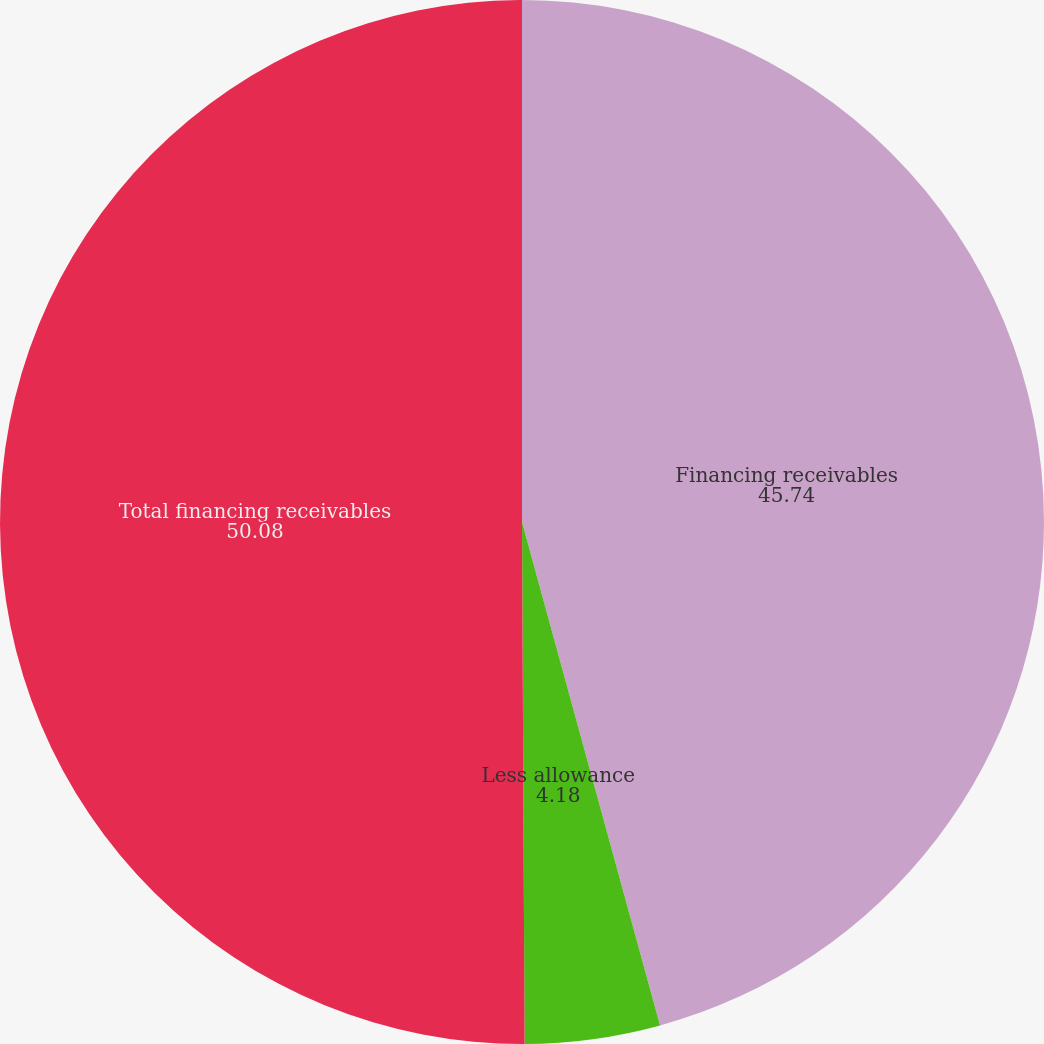Convert chart. <chart><loc_0><loc_0><loc_500><loc_500><pie_chart><fcel>Financing receivables<fcel>Less allowance<fcel>Total financing receivables<nl><fcel>45.74%<fcel>4.18%<fcel>50.08%<nl></chart> 